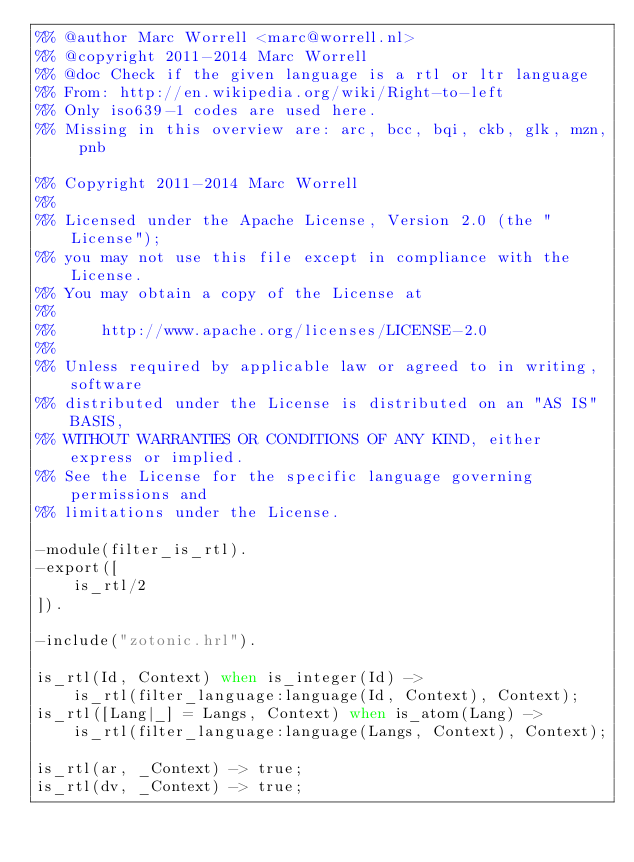Convert code to text. <code><loc_0><loc_0><loc_500><loc_500><_Erlang_>%% @author Marc Worrell <marc@worrell.nl>
%% @copyright 2011-2014 Marc Worrell
%% @doc Check if the given language is a rtl or ltr language
%% From: http://en.wikipedia.org/wiki/Right-to-left
%% Only iso639-1 codes are used here.
%% Missing in this overview are: arc, bcc, bqi, ckb, glk, mzn, pnb

%% Copyright 2011-2014 Marc Worrell
%%
%% Licensed under the Apache License, Version 2.0 (the "License");
%% you may not use this file except in compliance with the License.
%% You may obtain a copy of the License at
%% 
%%     http://www.apache.org/licenses/LICENSE-2.0
%% 
%% Unless required by applicable law or agreed to in writing, software
%% distributed under the License is distributed on an "AS IS" BASIS,
%% WITHOUT WARRANTIES OR CONDITIONS OF ANY KIND, either express or implied.
%% See the License for the specific language governing permissions and
%% limitations under the License.

-module(filter_is_rtl).
-export([
    is_rtl/2
]).

-include("zotonic.hrl").

is_rtl(Id, Context) when is_integer(Id) ->
    is_rtl(filter_language:language(Id, Context), Context);
is_rtl([Lang|_] = Langs, Context) when is_atom(Lang) ->
    is_rtl(filter_language:language(Langs, Context), Context);

is_rtl(ar, _Context) -> true;
is_rtl(dv, _Context) -> true;</code> 